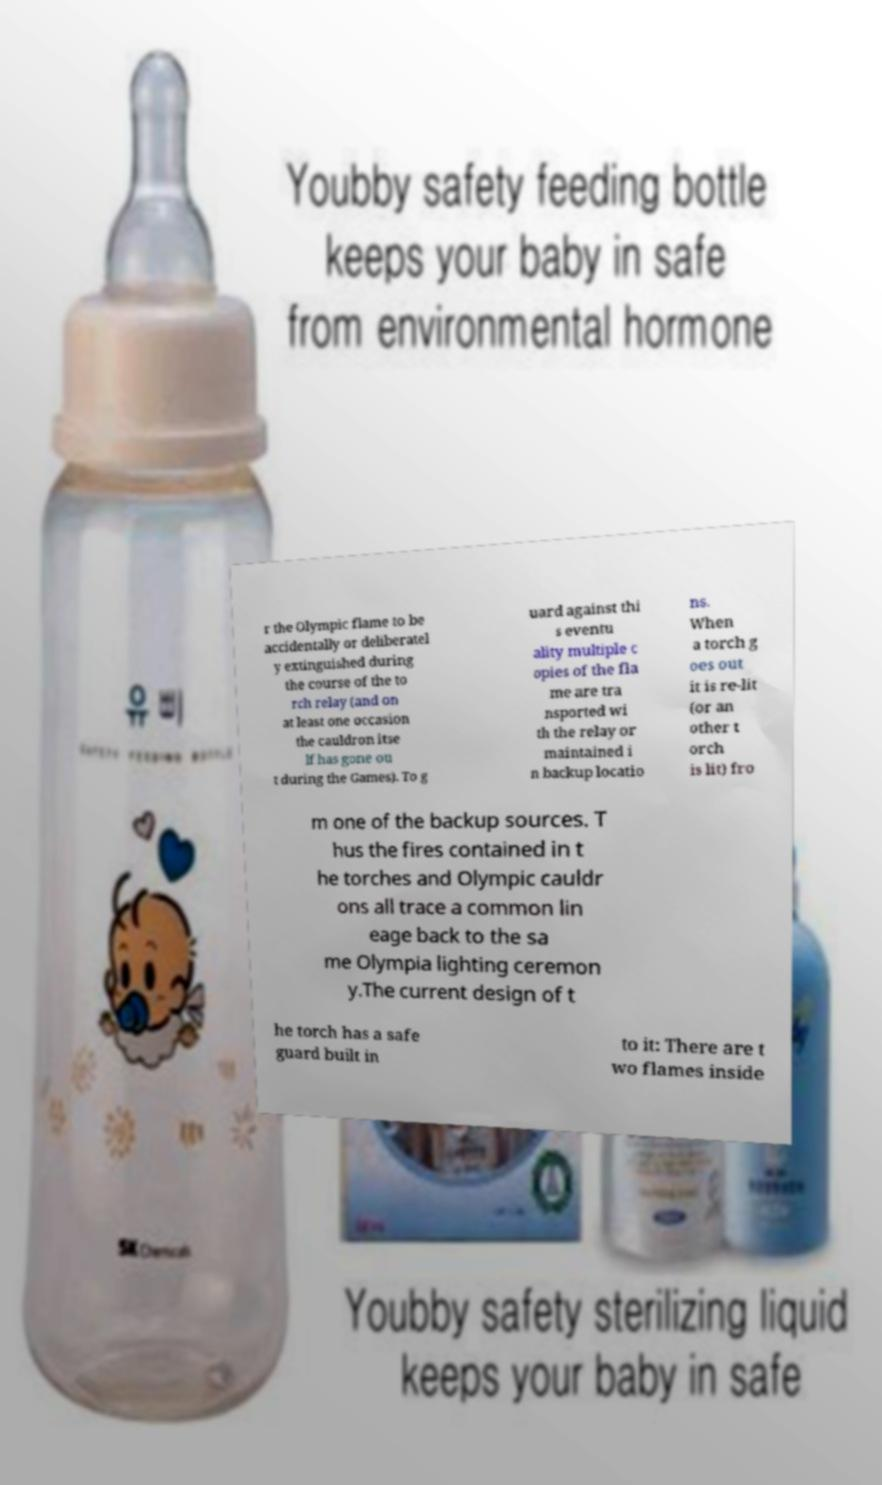There's text embedded in this image that I need extracted. Can you transcribe it verbatim? r the Olympic flame to be accidentally or deliberatel y extinguished during the course of the to rch relay (and on at least one occasion the cauldron itse lf has gone ou t during the Games). To g uard against thi s eventu ality multiple c opies of the fla me are tra nsported wi th the relay or maintained i n backup locatio ns. When a torch g oes out it is re-lit (or an other t orch is lit) fro m one of the backup sources. T hus the fires contained in t he torches and Olympic cauldr ons all trace a common lin eage back to the sa me Olympia lighting ceremon y.The current design of t he torch has a safe guard built in to it: There are t wo flames inside 